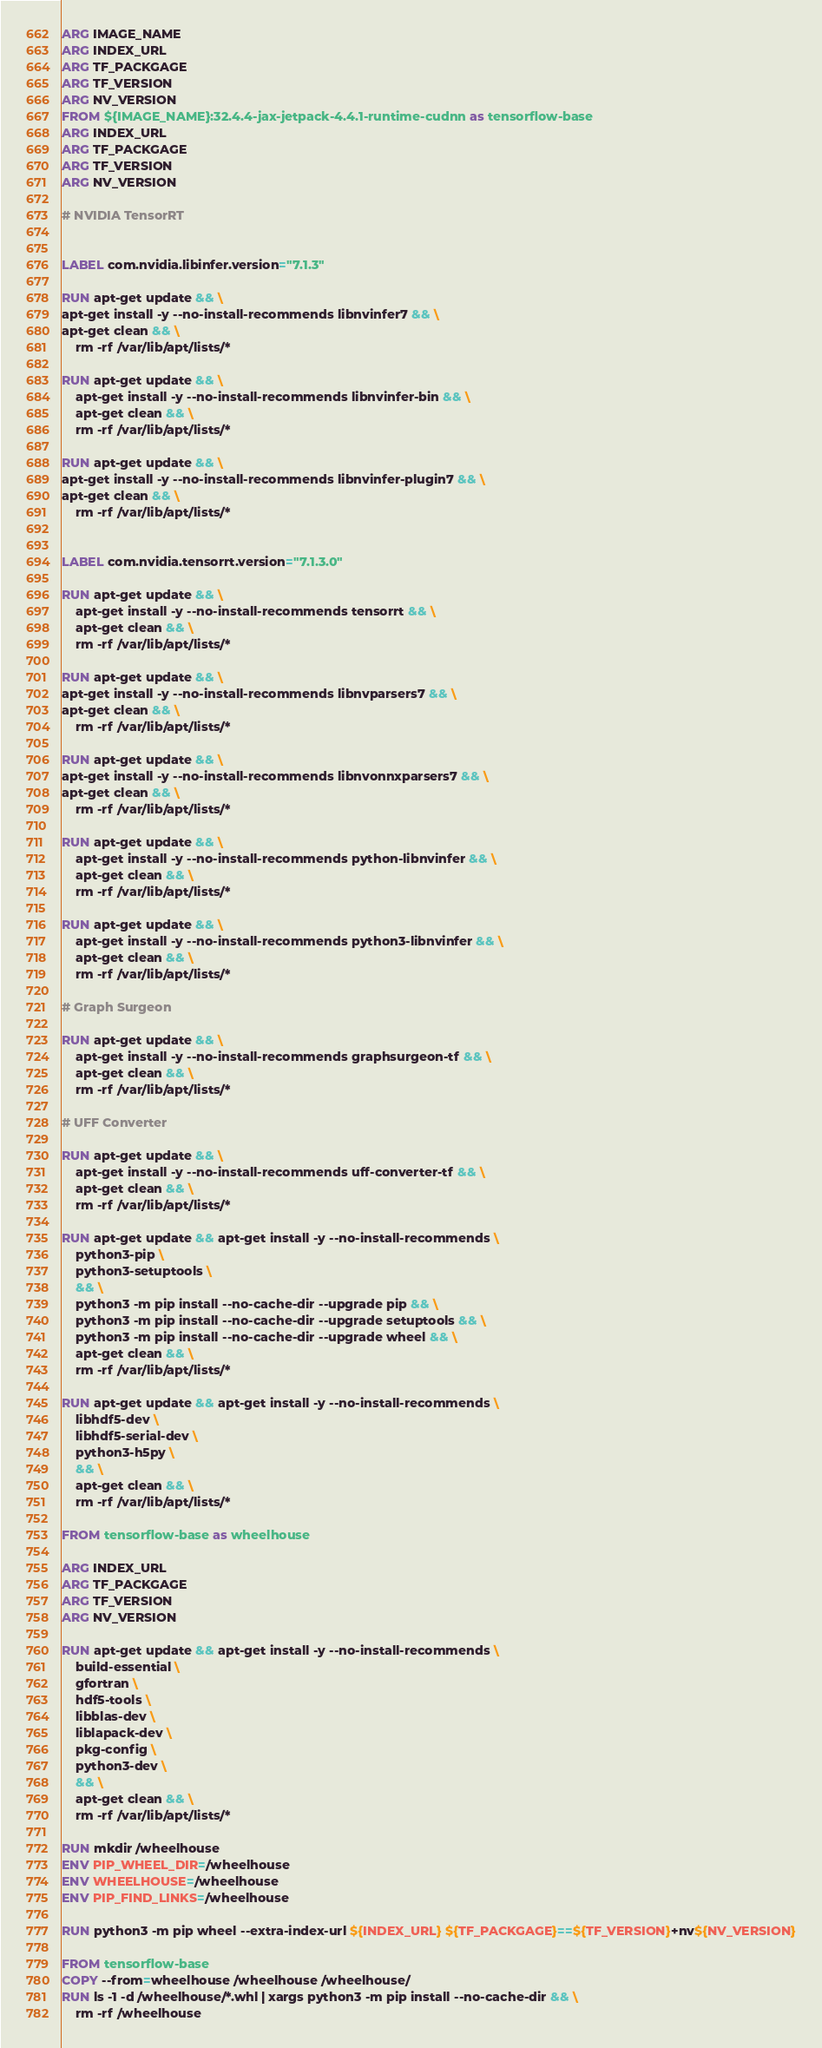Convert code to text. <code><loc_0><loc_0><loc_500><loc_500><_Dockerfile_>ARG IMAGE_NAME
ARG INDEX_URL
ARG TF_PACKGAGE
ARG TF_VERSION
ARG NV_VERSION
FROM ${IMAGE_NAME}:32.4.4-jax-jetpack-4.4.1-runtime-cudnn as tensorflow-base
ARG INDEX_URL
ARG TF_PACKGAGE
ARG TF_VERSION
ARG NV_VERSION

# NVIDIA TensorRT


LABEL com.nvidia.libinfer.version="7.1.3"

RUN apt-get update && \
apt-get install -y --no-install-recommends libnvinfer7 && \
apt-get clean && \
    rm -rf /var/lib/apt/lists/*

RUN apt-get update && \
    apt-get install -y --no-install-recommends libnvinfer-bin && \
    apt-get clean && \
    rm -rf /var/lib/apt/lists/*

RUN apt-get update && \
apt-get install -y --no-install-recommends libnvinfer-plugin7 && \
apt-get clean && \
    rm -rf /var/lib/apt/lists/*


LABEL com.nvidia.tensorrt.version="7.1.3.0"

RUN apt-get update && \
    apt-get install -y --no-install-recommends tensorrt && \
    apt-get clean && \
    rm -rf /var/lib/apt/lists/*

RUN apt-get update && \
apt-get install -y --no-install-recommends libnvparsers7 && \
apt-get clean && \
    rm -rf /var/lib/apt/lists/*

RUN apt-get update && \
apt-get install -y --no-install-recommends libnvonnxparsers7 && \
apt-get clean && \
    rm -rf /var/lib/apt/lists/*

RUN apt-get update && \
    apt-get install -y --no-install-recommends python-libnvinfer && \
    apt-get clean && \
    rm -rf /var/lib/apt/lists/*

RUN apt-get update && \
    apt-get install -y --no-install-recommends python3-libnvinfer && \
    apt-get clean && \
    rm -rf /var/lib/apt/lists/*

# Graph Surgeon

RUN apt-get update && \
    apt-get install -y --no-install-recommends graphsurgeon-tf && \
    apt-get clean && \
    rm -rf /var/lib/apt/lists/*

# UFF Converter

RUN apt-get update && \
    apt-get install -y --no-install-recommends uff-converter-tf && \
    apt-get clean && \
    rm -rf /var/lib/apt/lists/*

RUN apt-get update && apt-get install -y --no-install-recommends \
    python3-pip \
    python3-setuptools \
    && \
    python3 -m pip install --no-cache-dir --upgrade pip && \
    python3 -m pip install --no-cache-dir --upgrade setuptools && \
    python3 -m pip install --no-cache-dir --upgrade wheel && \
    apt-get clean && \
    rm -rf /var/lib/apt/lists/*

RUN apt-get update && apt-get install -y --no-install-recommends \
    libhdf5-dev \
    libhdf5-serial-dev \
    python3-h5py \
    && \
    apt-get clean && \
    rm -rf /var/lib/apt/lists/*

FROM tensorflow-base as wheelhouse

ARG INDEX_URL
ARG TF_PACKGAGE
ARG TF_VERSION
ARG NV_VERSION

RUN apt-get update && apt-get install -y --no-install-recommends \
    build-essential \
    gfortran \
    hdf5-tools \
    libblas-dev \
    liblapack-dev \
    pkg-config \
    python3-dev \
    && \
    apt-get clean && \
    rm -rf /var/lib/apt/lists/*

RUN mkdir /wheelhouse
ENV PIP_WHEEL_DIR=/wheelhouse
ENV WHEELHOUSE=/wheelhouse
ENV PIP_FIND_LINKS=/wheelhouse

RUN python3 -m pip wheel --extra-index-url ${INDEX_URL} ${TF_PACKGAGE}==${TF_VERSION}+nv${NV_VERSION}

FROM tensorflow-base
COPY --from=wheelhouse /wheelhouse /wheelhouse/
RUN ls -1 -d /wheelhouse/*.whl | xargs python3 -m pip install --no-cache-dir && \
    rm -rf /wheelhouse</code> 